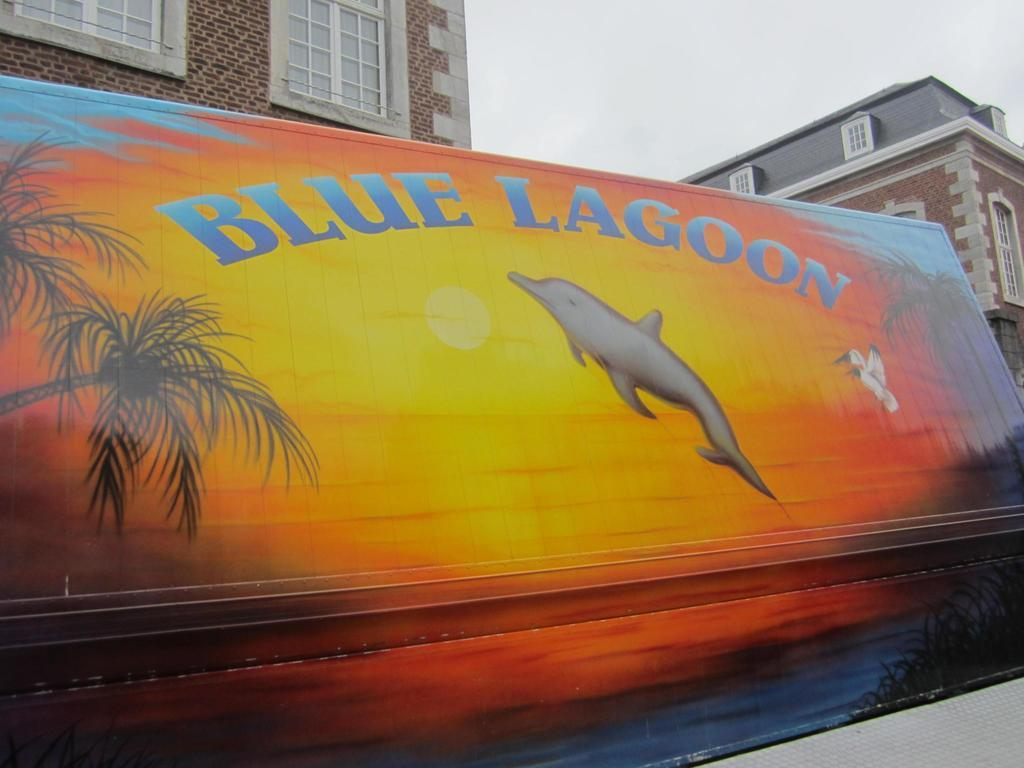What is depicted on the wall in the image? There is a painting on the wall in the image. What type of structures can be seen in the image? There are buildings with windows in the image. What part of the natural environment is visible in the image? The sky is visible in the image. How would you describe the weather based on the appearance of the sky? The sky appears to be cloudy in the image. What type of art can be seen being created by the cast in the image? There is no cast present in the image, nor is any art being created. 